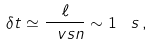Convert formula to latex. <formula><loc_0><loc_0><loc_500><loc_500>\delta t \simeq \frac { \ell } { \ v s n } \sim 1 \, \ s \, ,</formula> 